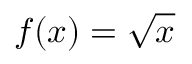<formula> <loc_0><loc_0><loc_500><loc_500>f ( x ) = { \sqrt { x } }</formula> 